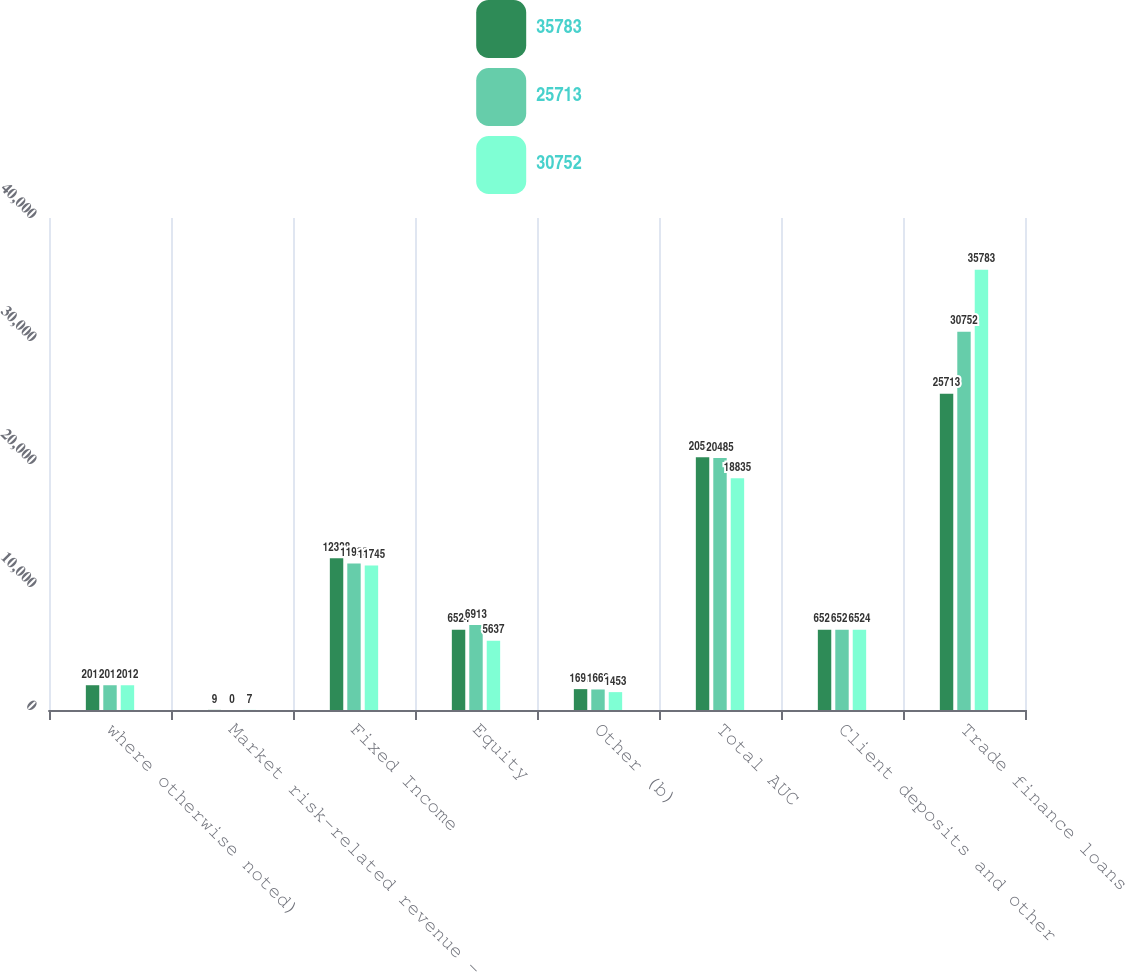<chart> <loc_0><loc_0><loc_500><loc_500><stacked_bar_chart><ecel><fcel>where otherwise noted)<fcel>Market risk-related revenue -<fcel>Fixed Income<fcel>Equity<fcel>Other (b)<fcel>Total AUC<fcel>Client deposits and other<fcel>Trade finance loans<nl><fcel>35783<fcel>2014<fcel>9<fcel>12328<fcel>6524<fcel>1697<fcel>20549<fcel>6524<fcel>25713<nl><fcel>25713<fcel>2013<fcel>0<fcel>11903<fcel>6913<fcel>1669<fcel>20485<fcel>6524<fcel>30752<nl><fcel>30752<fcel>2012<fcel>7<fcel>11745<fcel>5637<fcel>1453<fcel>18835<fcel>6524<fcel>35783<nl></chart> 